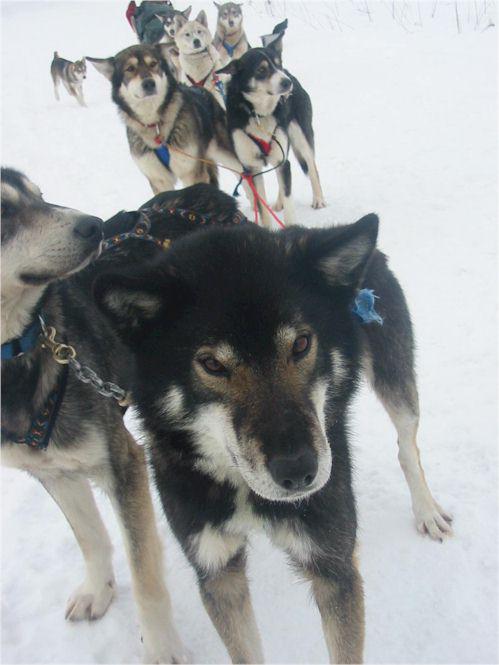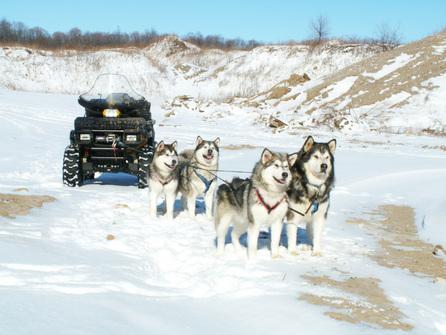The first image is the image on the left, the second image is the image on the right. Assess this claim about the two images: "At least one lead dog clearly has their tongue hanging out.". Correct or not? Answer yes or no. No. The first image is the image on the left, the second image is the image on the right. Given the left and right images, does the statement "A team of dogs is heading down a path lined with snow-covered trees." hold true? Answer yes or no. No. 